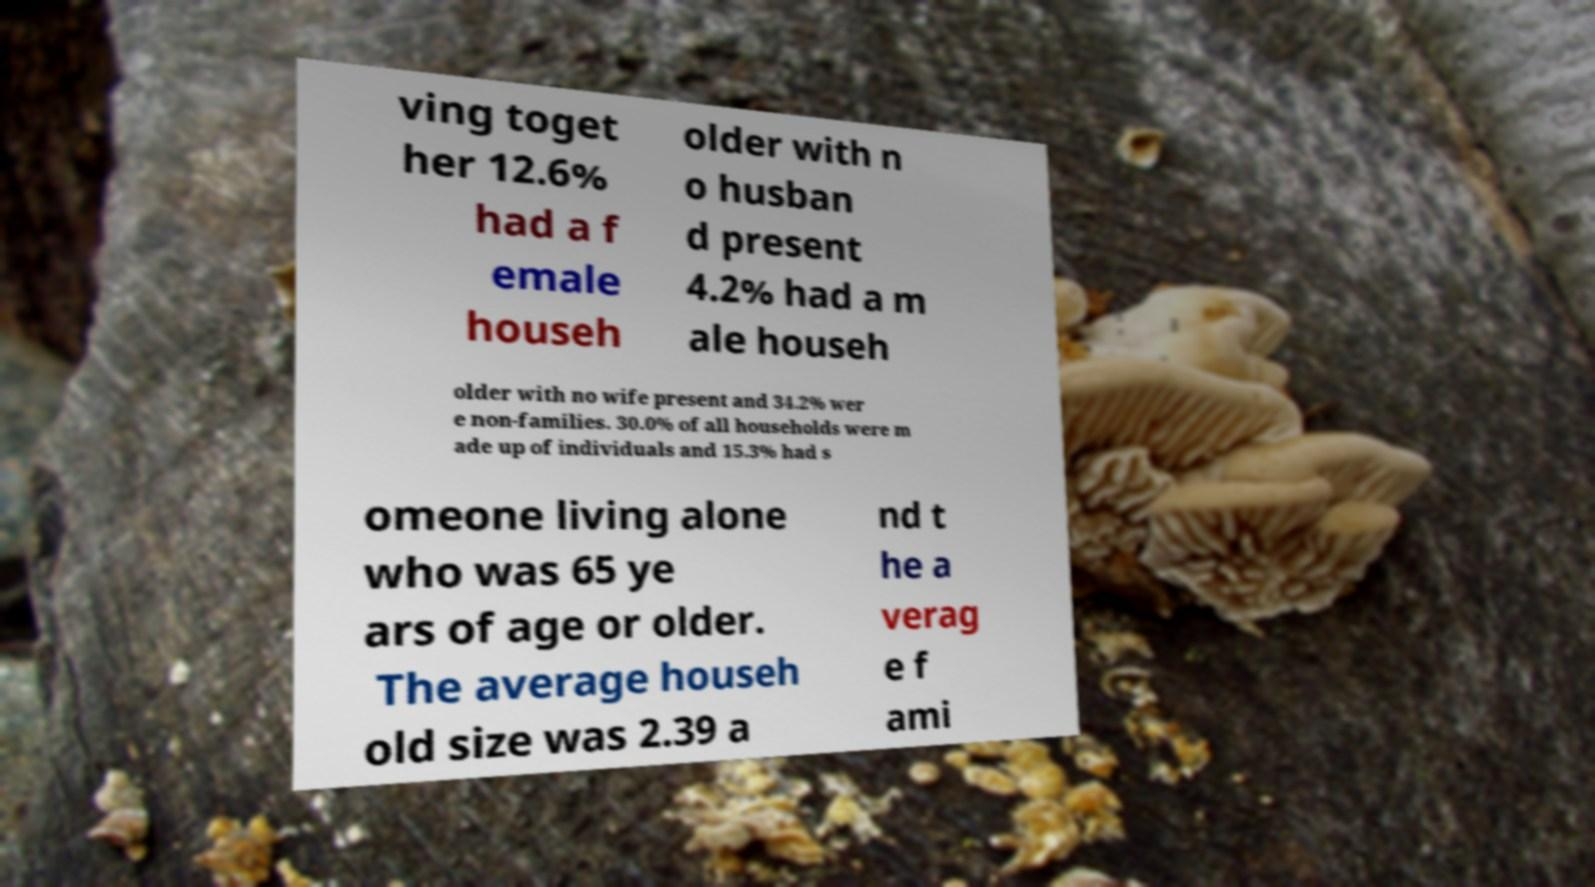Could you extract and type out the text from this image? ving toget her 12.6% had a f emale househ older with n o husban d present 4.2% had a m ale househ older with no wife present and 34.2% wer e non-families. 30.0% of all households were m ade up of individuals and 15.3% had s omeone living alone who was 65 ye ars of age or older. The average househ old size was 2.39 a nd t he a verag e f ami 